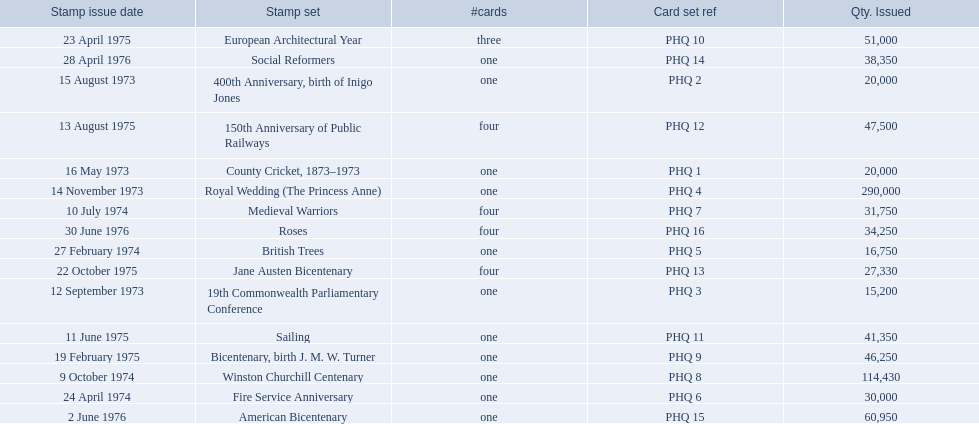What are all the stamp sets? County Cricket, 1873–1973, 400th Anniversary, birth of Inigo Jones, 19th Commonwealth Parliamentary Conference, Royal Wedding (The Princess Anne), British Trees, Fire Service Anniversary, Medieval Warriors, Winston Churchill Centenary, Bicentenary, birth J. M. W. Turner, European Architectural Year, Sailing, 150th Anniversary of Public Railways, Jane Austen Bicentenary, Social Reformers, American Bicentenary, Roses. For these sets, what were the quantities issued? 20,000, 20,000, 15,200, 290,000, 16,750, 30,000, 31,750, 114,430, 46,250, 51,000, 41,350, 47,500, 27,330, 38,350, 60,950, 34,250. Of these, which quantity is above 200,000? 290,000. What is the stamp set corresponding to this quantity? Royal Wedding (The Princess Anne). 